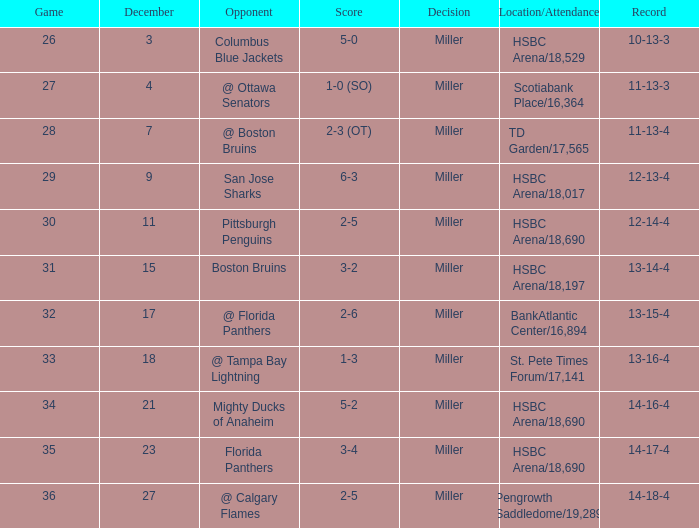Name the least december for hsbc arena/18,017 9.0. Could you parse the entire table as a dict? {'header': ['Game', 'December', 'Opponent', 'Score', 'Decision', 'Location/Attendance', 'Record'], 'rows': [['26', '3', 'Columbus Blue Jackets', '5-0', 'Miller', 'HSBC Arena/18,529', '10-13-3'], ['27', '4', '@ Ottawa Senators', '1-0 (SO)', 'Miller', 'Scotiabank Place/16,364', '11-13-3'], ['28', '7', '@ Boston Bruins', '2-3 (OT)', 'Miller', 'TD Garden/17,565', '11-13-4'], ['29', '9', 'San Jose Sharks', '6-3', 'Miller', 'HSBC Arena/18,017', '12-13-4'], ['30', '11', 'Pittsburgh Penguins', '2-5', 'Miller', 'HSBC Arena/18,690', '12-14-4'], ['31', '15', 'Boston Bruins', '3-2', 'Miller', 'HSBC Arena/18,197', '13-14-4'], ['32', '17', '@ Florida Panthers', '2-6', 'Miller', 'BankAtlantic Center/16,894', '13-15-4'], ['33', '18', '@ Tampa Bay Lightning', '1-3', 'Miller', 'St. Pete Times Forum/17,141', '13-16-4'], ['34', '21', 'Mighty Ducks of Anaheim', '5-2', 'Miller', 'HSBC Arena/18,690', '14-16-4'], ['35', '23', 'Florida Panthers', '3-4', 'Miller', 'HSBC Arena/18,690', '14-17-4'], ['36', '27', '@ Calgary Flames', '2-5', 'Miller', 'Pengrowth Saddledome/19,289', '14-18-4']]} 